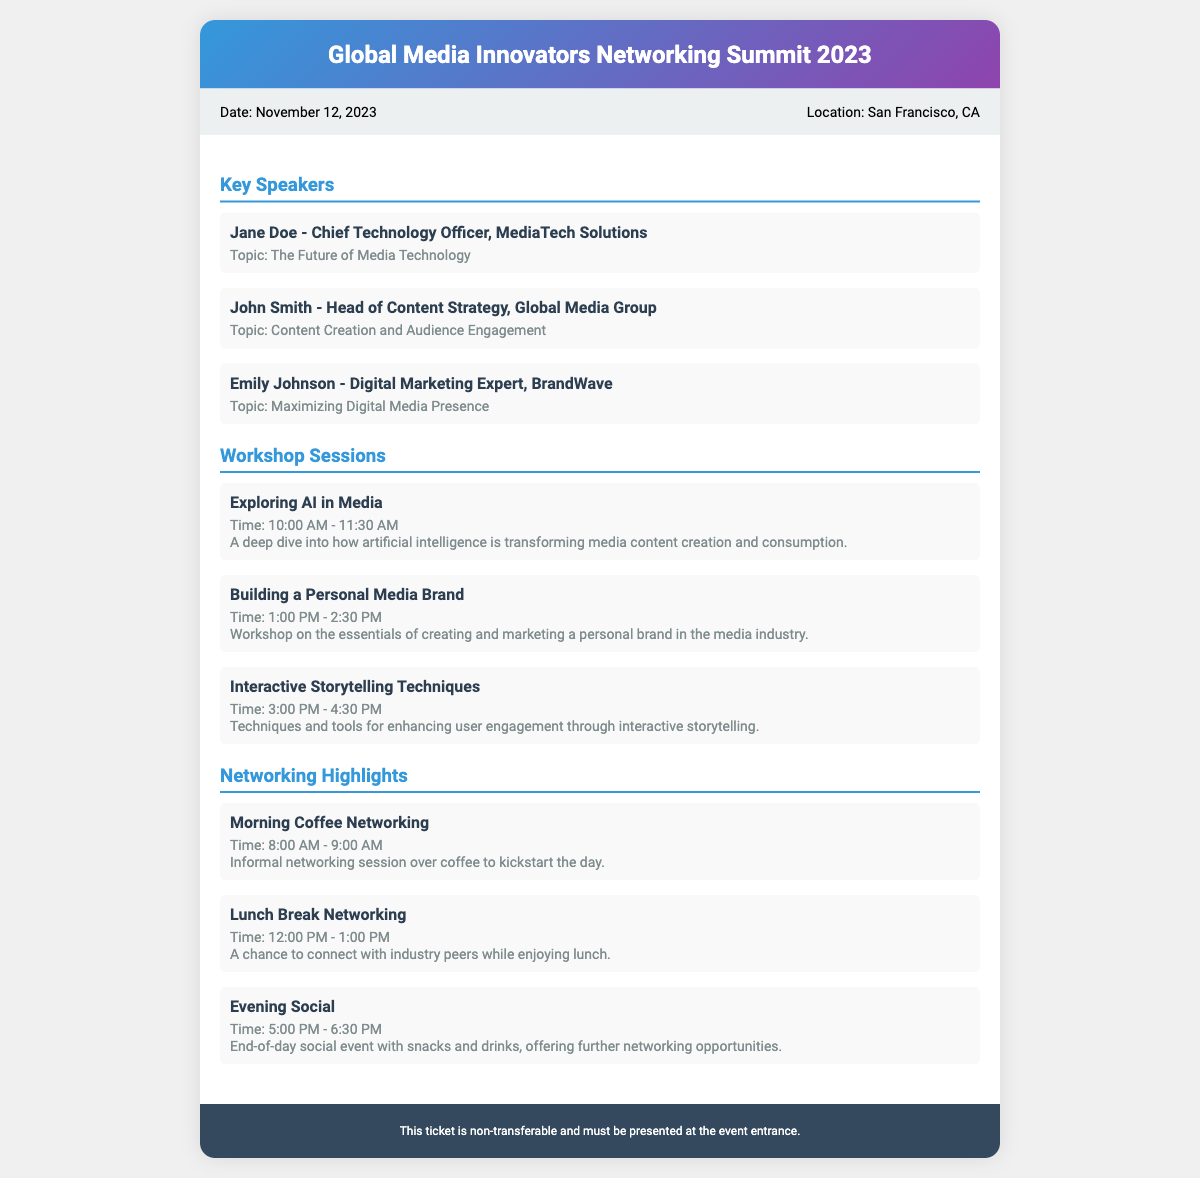What is the event date? The event date is specified in the ticket information section of the document.
Answer: November 12, 2023 Where is the event located? The location is mentioned in the ticket info section of the document.
Answer: San Francisco, CA Who is the Chief Technology Officer for MediaTech Solutions? The person's name and title are listed in the key speakers section.
Answer: Jane Doe What is the topic of John Smith's presentation? The topic is given in the key speakers section corresponding to John Smith.
Answer: Content Creation and Audience Engagement What time does the 'Exploring AI in Media' session start? The start time is detailed in the workshop sessions section of the document.
Answer: 10:00 AM How long is the 'Lunch Break Networking' scheduled for? The duration can be inferred by comparing the start and end times in the networking highlights.
Answer: 1 hour What is a featured activity during the evening? This question asks for a specific social event mentioned under networking highlights.
Answer: Evening Social What is unique about the ticket? The ticket contains a specific clause about its usability.
Answer: Non-transferable 